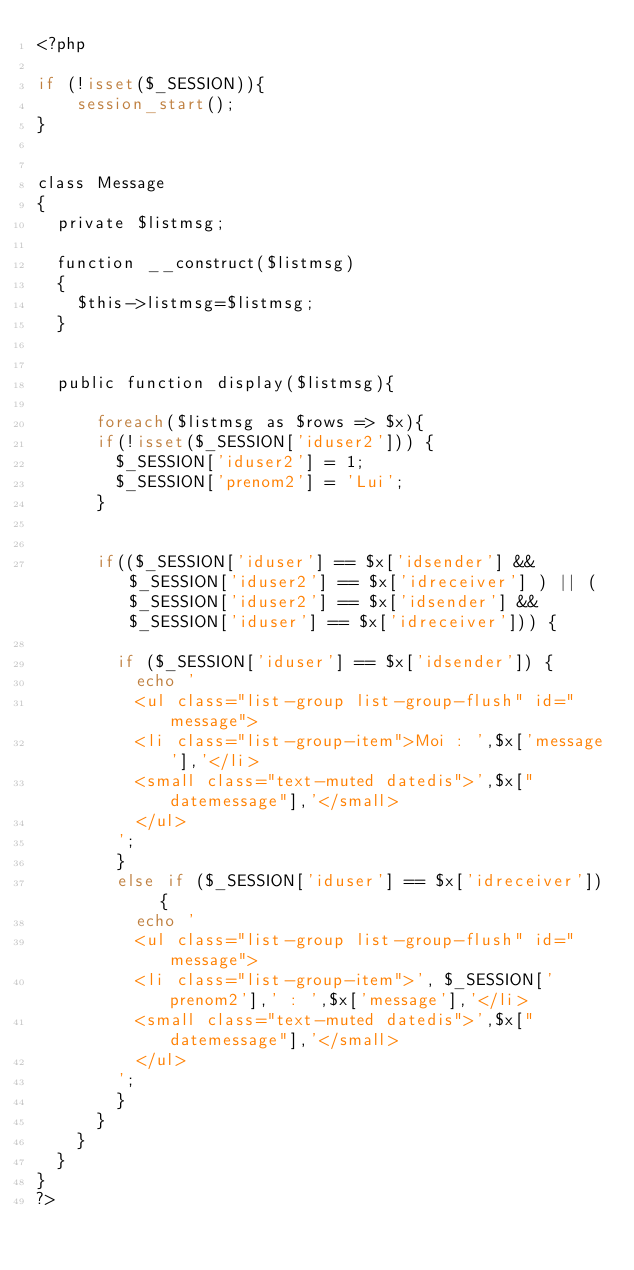Convert code to text. <code><loc_0><loc_0><loc_500><loc_500><_PHP_><?php

if (!isset($_SESSION)){
    session_start();
}


class Message
{
	private $listmsg;

	function __construct($listmsg)
	{
		$this->listmsg=$listmsg;
	}


	public function display($listmsg){

    	foreach($listmsg as $rows => $x){
			if(!isset($_SESSION['iduser2'])) {
				$_SESSION['iduser2'] = 1;
				$_SESSION['prenom2'] = 'Lui';
			}
				

			if(($_SESSION['iduser'] == $x['idsender'] &&  $_SESSION['iduser2'] == $x['idreceiver'] ) || ($_SESSION['iduser2'] == $x['idsender'] &&  $_SESSION['iduser'] == $x['idreceiver'])) {

				if ($_SESSION['iduser'] == $x['idsender']) {
					echo '
					<ul class="list-group list-group-flush" id="message">
					<li class="list-group-item">Moi : ',$x['message'],'</li>
					<small class="text-muted datedis">',$x["datemessage"],'</small>
					</ul>
				';
				}
				else if ($_SESSION['iduser'] == $x['idreceiver']) {
					echo '
					<ul class="list-group list-group-flush" id="message">
					<li class="list-group-item">', $_SESSION['prenom2'],' : ',$x['message'],'</li>
					<small class="text-muted datedis">',$x["datemessage"],'</small>
					</ul>
				';
				}
			}
		}
	}
}
?>
</code> 